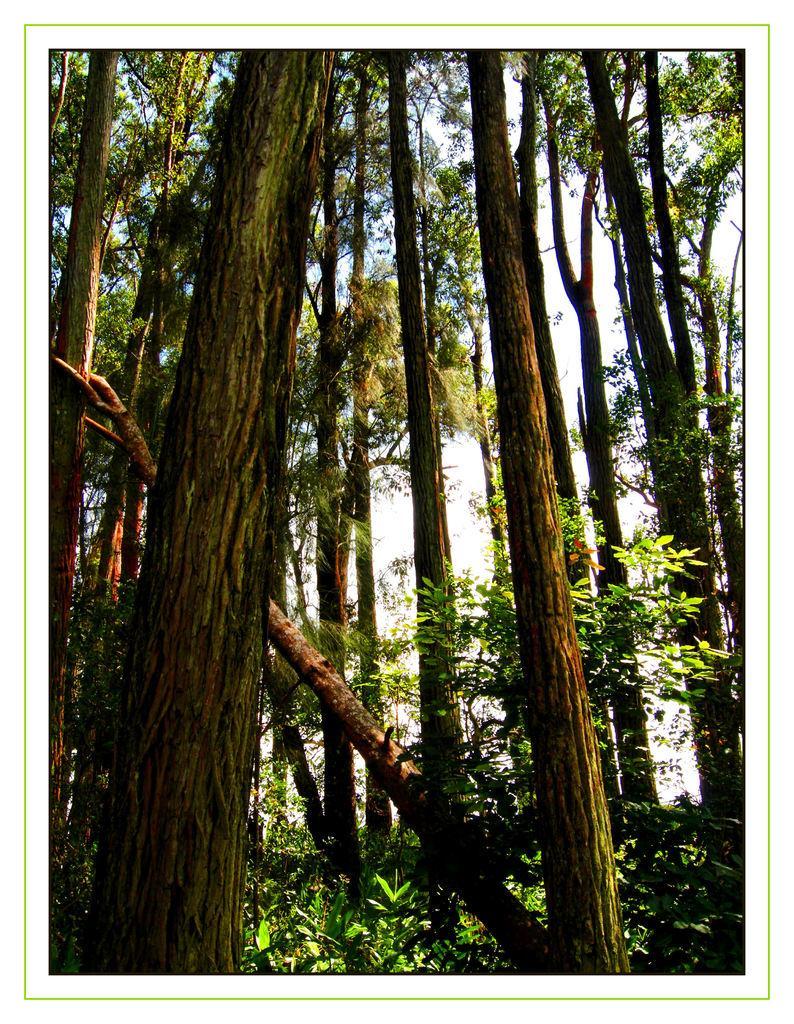Describe this image in one or two sentences. In this image there are a group of trees and plants, in the background there is sky. 